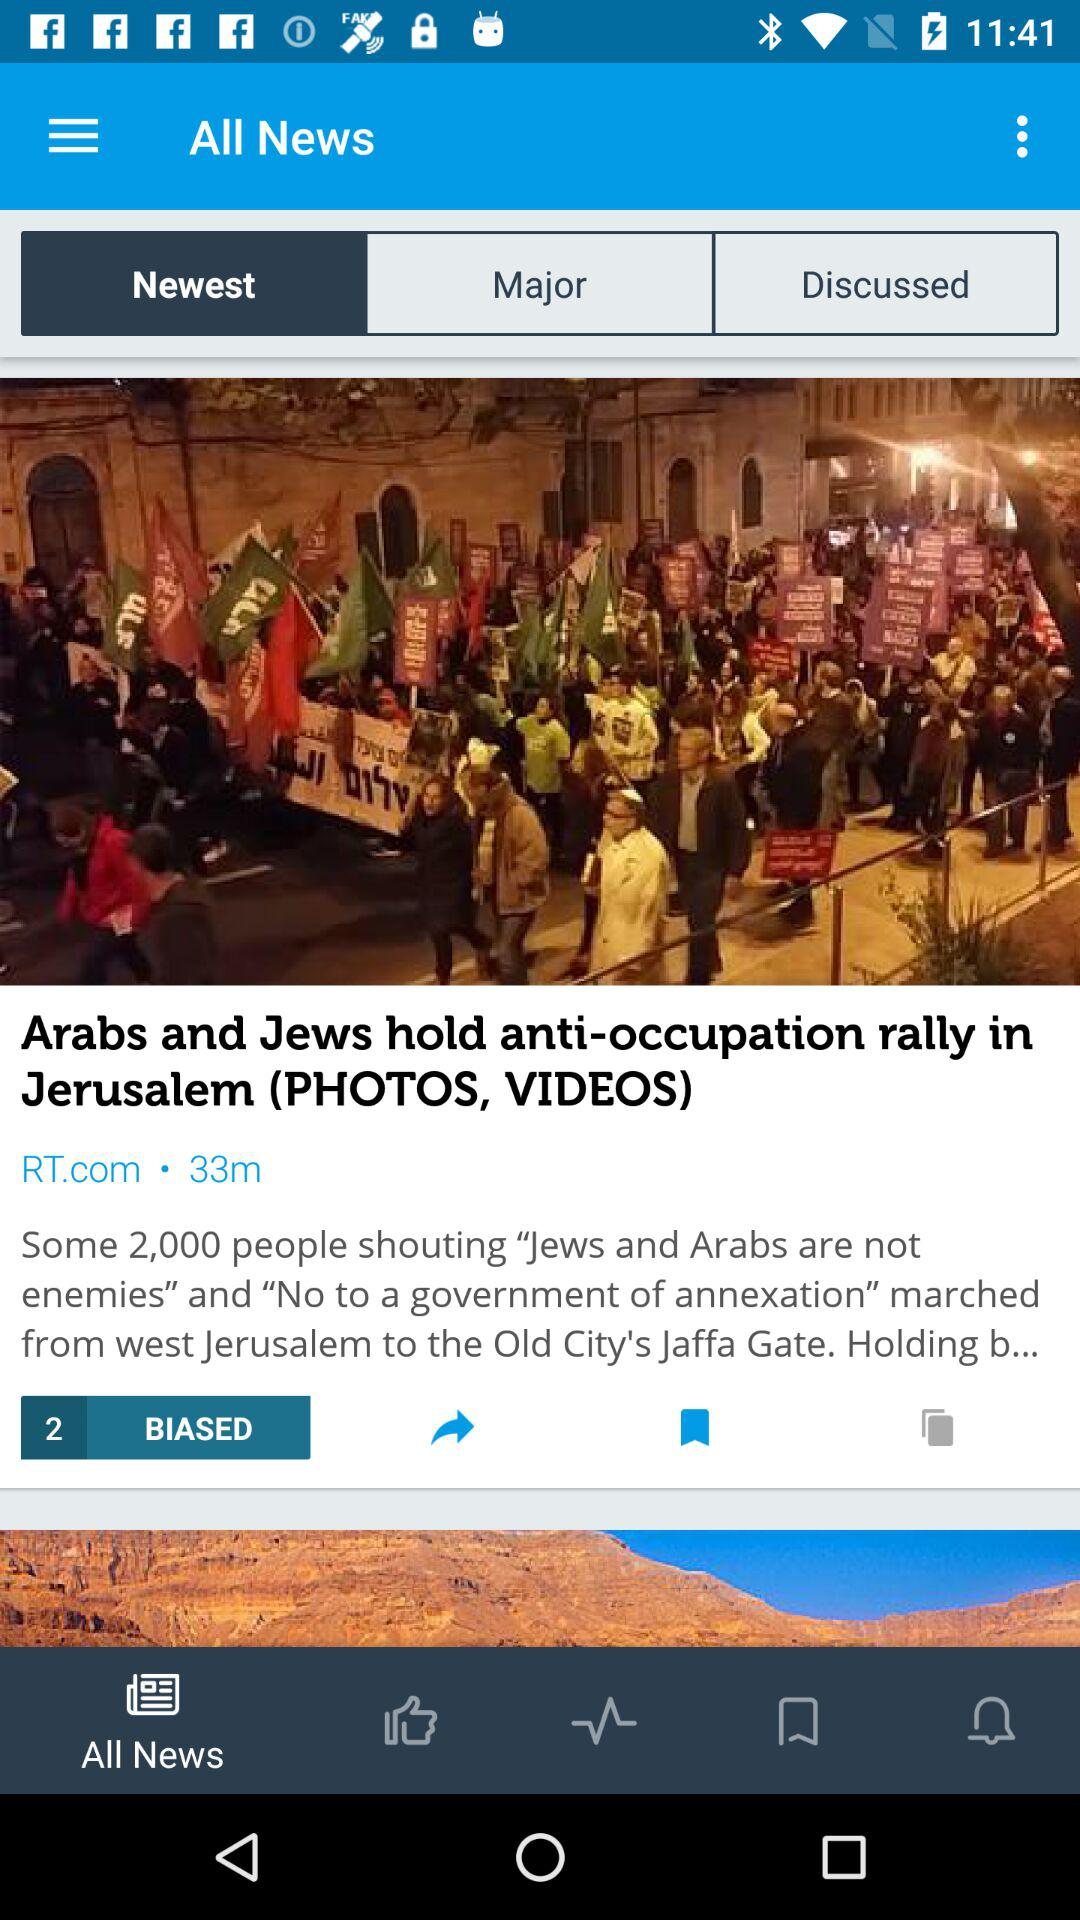How many minutes back was the news published? The news was published 33 minutes back. 